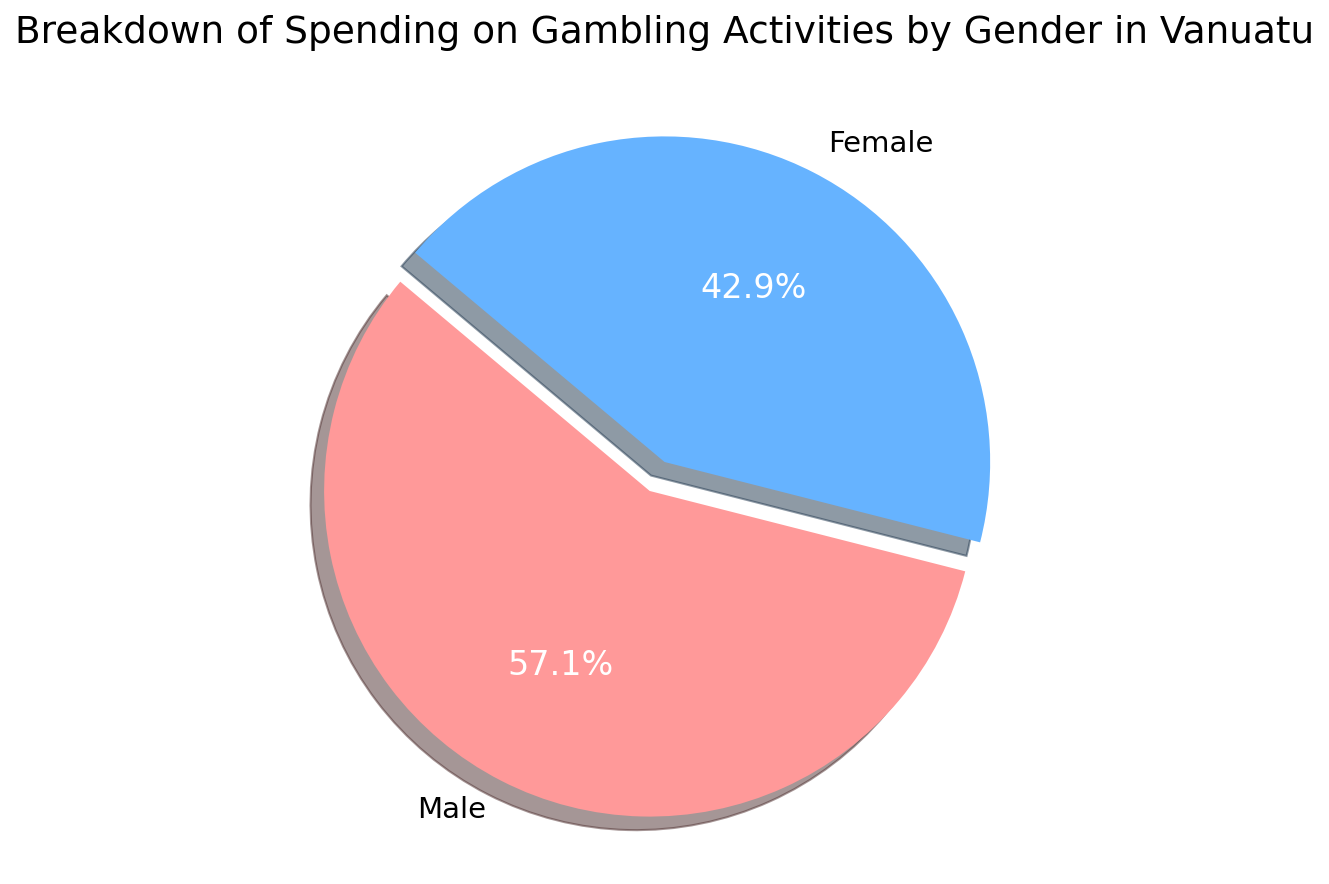What percentage of gambling spending is attributed to females? According to the pie chart, the labeling for females shows their percentage of gambling spending.
Answer: 42.9% Which gender has a higher spending on gambling activities? By looking at the pie chart, you can see that the male section is larger than the female section.
Answer: Male How much more do males spend on gambling compared to females? First, note the spending amounts for males and females from the data: 1,200,000 Vatu for males and 900,000 Vatu for females. Subtract the female spending from the male spending: 1,200,000 - 900,000 = 300,000 Vatu.
Answer: 300,000 Vatu What is the total spending on gambling activities for both genders combined? Sum the spending amounts provided in the data: 1,200,000 Vatu for males + 900,000 Vatu for females = 2,100,000 Vatu.
Answer: 2,100,000 Vatu If the total spending increases by 10%, how much will the new total be? First, calculate 10% of the total spending: 2,100,000 Vatu * 0.10 = 210,000 Vatu. Then, add this to the original total: 2,100,000 Vatu + 210,000 Vatu = 2,310,000 Vatu.
Answer: 2,310,000 Vatu What percentage of the total gambling spending is attributed to males? According to the pie chart, the labeling for males shows their percentage of gambling spending.
Answer: 57.1% What color represents the female gambling spending section in the pie chart? By observing the pie chart, the female section is represented in light blue.
Answer: Light blue If female spending were to increase by 50%, what would be the new total spending? First, calculate 50% of the female spending: 900,000 Vatu * 0.50 = 450,000 Vatu. Add this to the original female spending: 900,000 Vatu + 450,000 Vatu = 1,350,000 Vatu. Then, add this to the male spending: 1,200,000 Vatu + 1,350,000 Vatu = 2,550,000 Vatu.
Answer: 2,550,000 Vatu How does the pie chart visually emphasize the male spending segment? The male segment of the pie chart is exploded, meaning it is visually separated from the rest of the pie for emphasis, and it also has a shadow effect.
Answer: Exploded segment with shadow Which slice of the pie chart represents a larger proportion, and by how much? The male slice represents a larger proportion. To find by how much, subtract the female percentage from the male percentage: 57.1% - 42.9% = 14.2%.
Answer: Male by 14.2% 